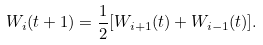<formula> <loc_0><loc_0><loc_500><loc_500>W _ { i } ( t + 1 ) = \frac { 1 } { 2 } [ W _ { i + 1 } ( t ) + W _ { i - 1 } ( t ) ] .</formula> 